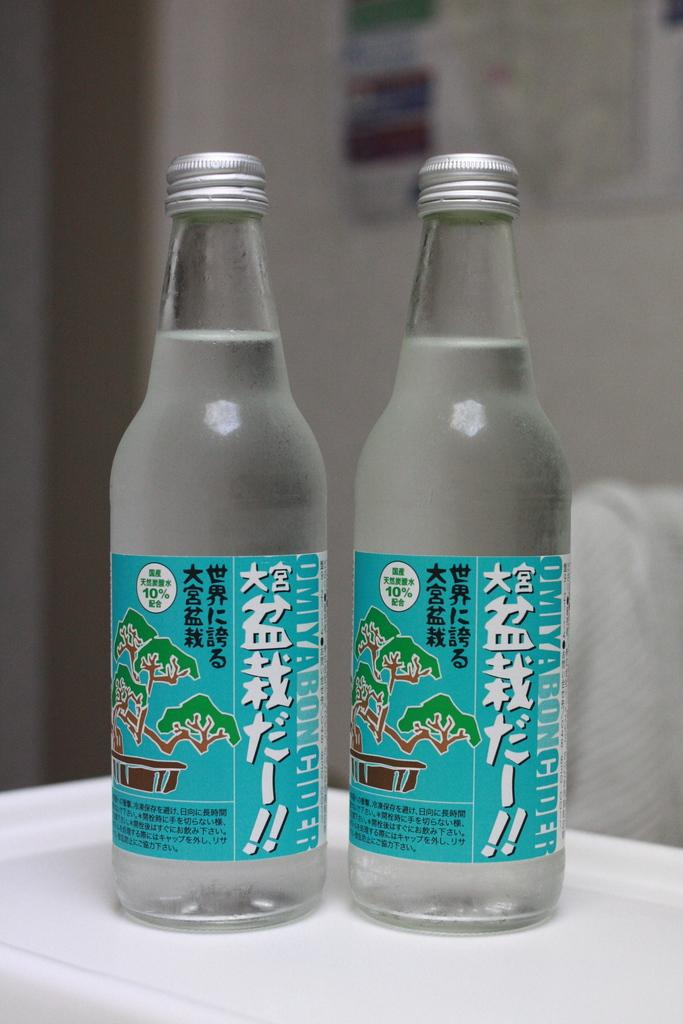<image>
Render a clear and concise summary of the photo. Two bottles of clear liquid and both saying 10% on it. 